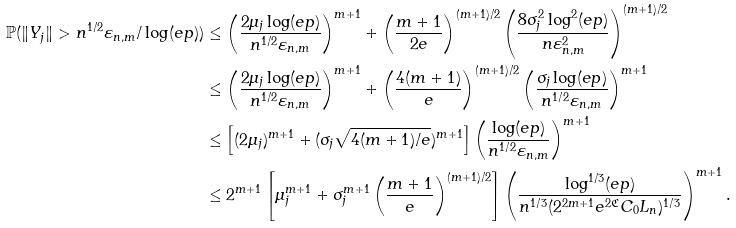<formula> <loc_0><loc_0><loc_500><loc_500>\mathbb { P } ( \| Y _ { j } \| > n ^ { 1 / 2 } \varepsilon _ { n , m } / \log ( e p ) ) & \leq \left ( \frac { 2 \mu _ { j } \log ( e p ) } { n ^ { 1 / 2 } \varepsilon _ { n , m } } \right ) ^ { m + 1 } + \left ( \frac { m + 1 } { 2 e } \right ) ^ { ( m + 1 ) / 2 } \left ( \frac { 8 \sigma _ { j } ^ { 2 } \log ^ { 2 } ( e p ) } { n \varepsilon _ { n , m } ^ { 2 } } \right ) ^ { ( m + 1 ) / 2 } \\ & \leq \left ( \frac { 2 \mu _ { j } \log ( e p ) } { n ^ { 1 / 2 } \varepsilon _ { n , m } } \right ) ^ { m + 1 } + \left ( \frac { 4 ( m + 1 ) } { e } \right ) ^ { ( m + 1 ) / 2 } \left ( \frac { \sigma _ { j } \log ( e p ) } { n ^ { 1 / 2 } \varepsilon _ { n , m } } \right ) ^ { m + 1 } \\ & \leq \left [ ( 2 \mu _ { j } ) ^ { m + 1 } + ( \sigma _ { j } \sqrt { 4 ( m + 1 ) / e } ) ^ { m + 1 } \right ] \left ( \frac { \log ( e p ) } { n ^ { 1 / 2 } \varepsilon _ { n , m } } \right ) ^ { m + 1 } \\ & \leq 2 ^ { m + 1 } \left [ \mu _ { j } ^ { m + 1 } + \sigma _ { j } ^ { m + 1 } \left ( { \frac { m + 1 } { e } } \right ) ^ { ( m + 1 ) / 2 } \right ] \left ( \frac { \log ^ { 1 / 3 } ( e p ) } { n ^ { 1 / 3 } ( 2 ^ { 2 m + 1 } e ^ { 2 \mathfrak { C } } C _ { 0 } L _ { n } ) ^ { 1 / 3 } } \right ) ^ { m + 1 } .</formula> 